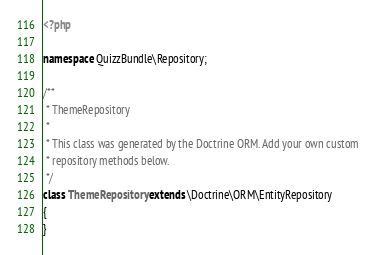<code> <loc_0><loc_0><loc_500><loc_500><_PHP_><?php

namespace QuizzBundle\Repository;

/**
 * ThemeRepository
 *
 * This class was generated by the Doctrine ORM. Add your own custom
 * repository methods below.
 */
class ThemeRepository extends \Doctrine\ORM\EntityRepository
{
}
</code> 